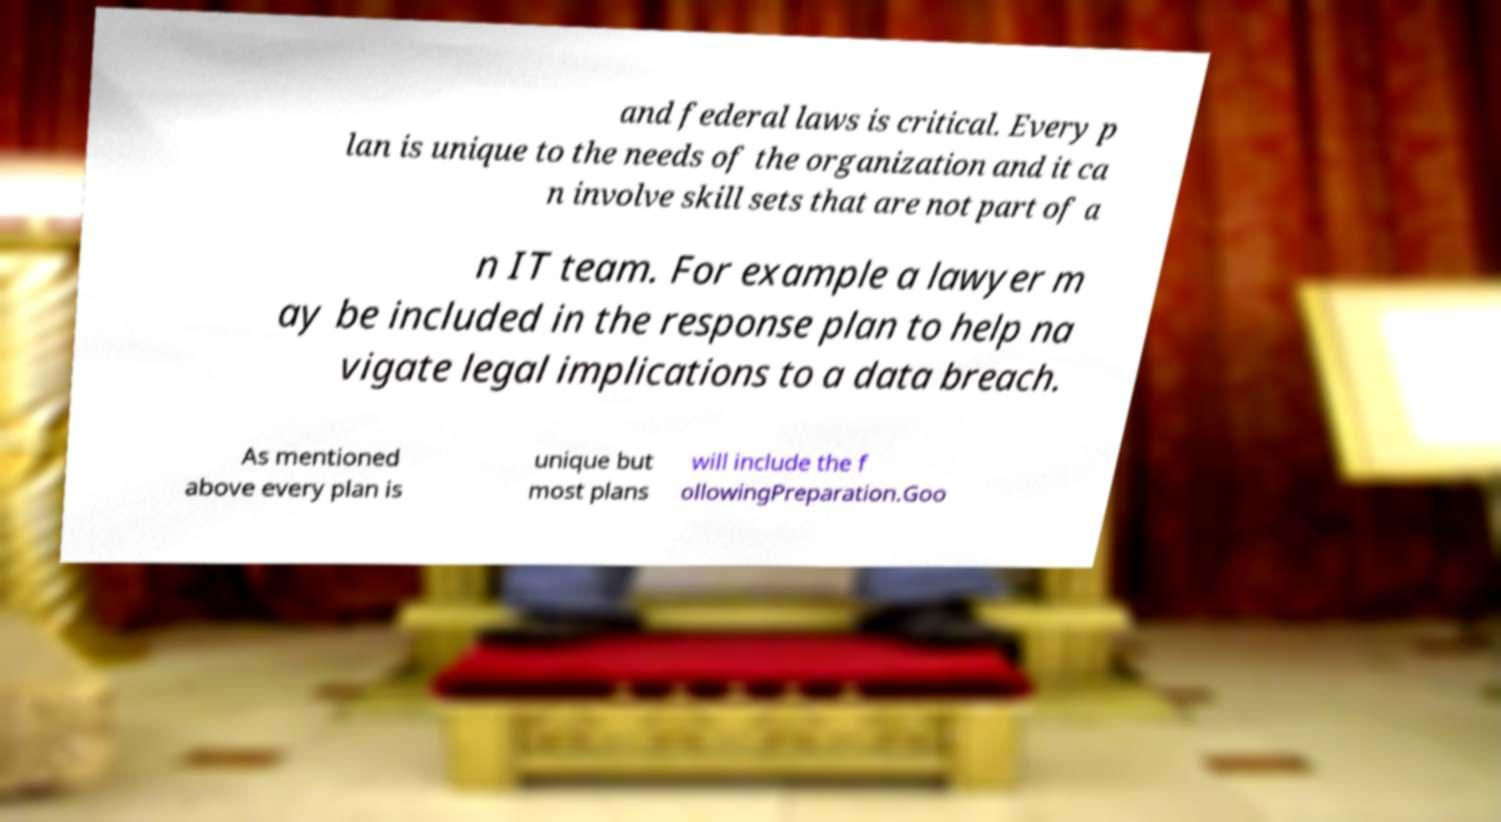There's text embedded in this image that I need extracted. Can you transcribe it verbatim? and federal laws is critical. Every p lan is unique to the needs of the organization and it ca n involve skill sets that are not part of a n IT team. For example a lawyer m ay be included in the response plan to help na vigate legal implications to a data breach. As mentioned above every plan is unique but most plans will include the f ollowingPreparation.Goo 